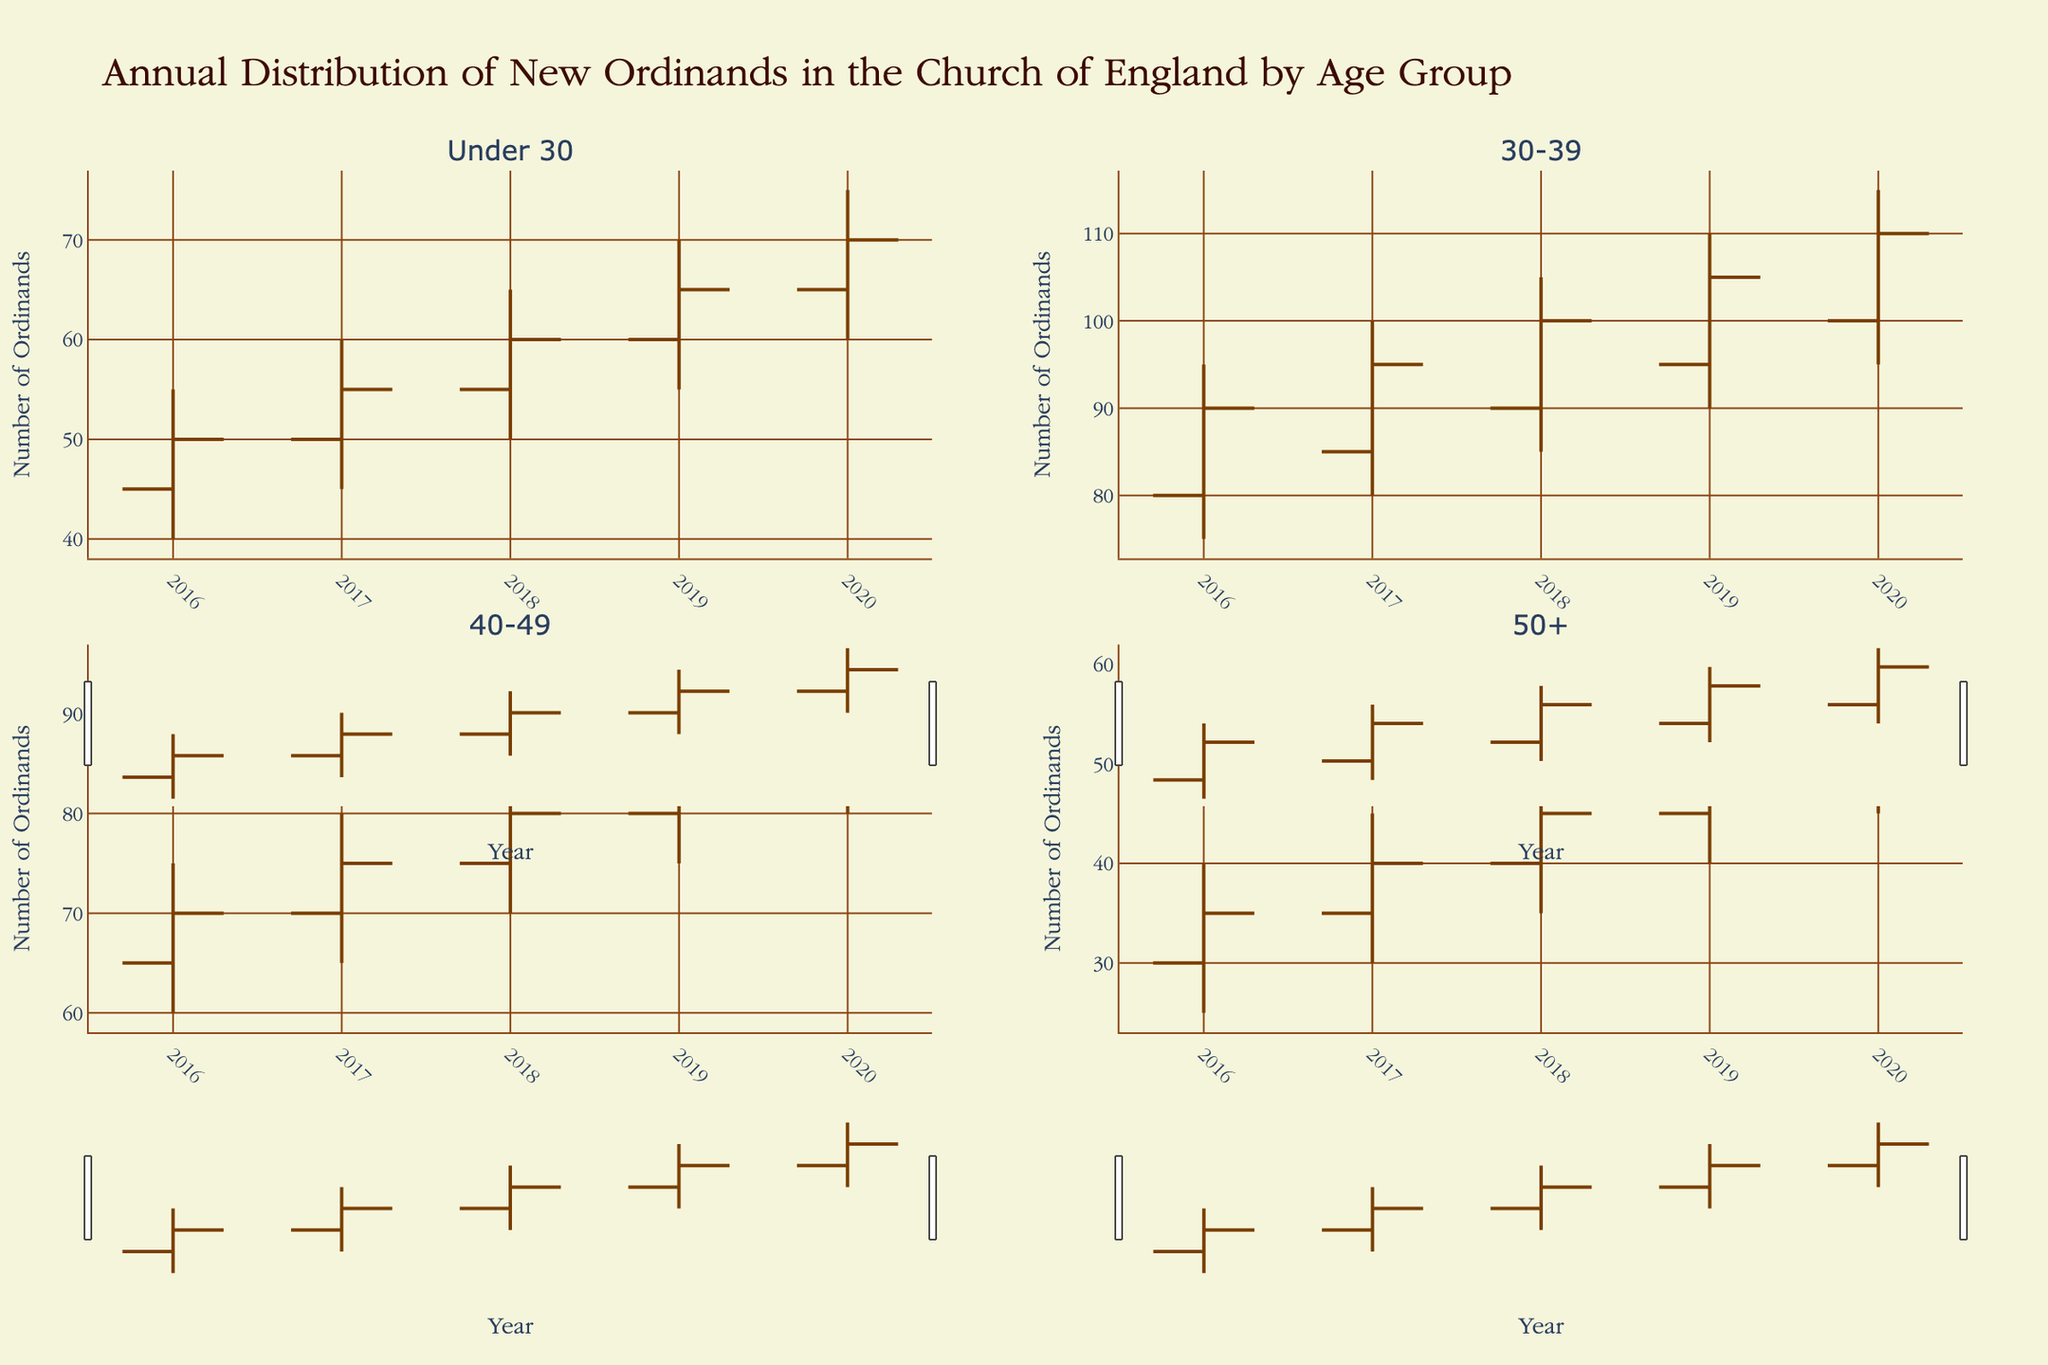What is the title of the figure? The title of the figure is displayed prominently at the top of the chart. It provides information about the contents of the chart.
Answer: Annual Distribution of New Ordinands in the Church of England by Age Group Which age group had the highest number of ordinands in 2020? To find this, look at the "High" value for the year 2020 in each subplot.
Answer: 30-39 What is the trend in the number of ordinands for the "Under 30" age group from 2016 to 2020? Observe the "Close" values in the "Under 30" subplot for each year from 2016 to 2020. Since the "Close" values are increasing year by year, there is an upward trend.
Answer: Increasing In which year did the "50+" age group see the lowest number of ordinands and what was the value? Look for the lowest "Low" value in the 50+ subplot across all years and identify the corresponding year.
Answer: 2016, 25 What was the average number of ordinands at the "Close" for the "40-49" age group over the years? Sum the "Close" values from 2016 to 2020 for the "40-49" age group and divide by the number of years (5). (70+75+80+85+90)/5 = 80
Answer: 80 Comparing 2018 and 2019, which age group saw the greatest increase in the number of ordinands? For each age group, calculate the difference in the "Close" values between 2018 and 2019. The largest difference will give the answer.
Answer: 30-39 What is the relationship between the "open" and "close" values for the 30-39 age group in 2020? Compare the "open" and "close" values for the 30-39 age group in 2020. Since the "open" value is 100 and the "close" value is 110, "close" is greater than "open".
Answer: Close is greater Which age group had the most stable number of ordinands from year to year, and how can you tell? Stability can be inferred by looking at the range of "High" to "Low" values. The "Under 30" group shows a consistent increase without significant fluctuations.
Answer: Under 30 In 2017, which age group had the smallest range between its highest and lowest number of ordinands? Calculate the range (High - Low) for each age group in 2017 and determine the smallest.
Answer: 50+ How did the "40-49" age group's highest number of ordinands change from 2016 to 2020? Examine the "High" values in the "40-49" subplot for these years. The values increase year by year from 75 to 95.
Answer: Increased 